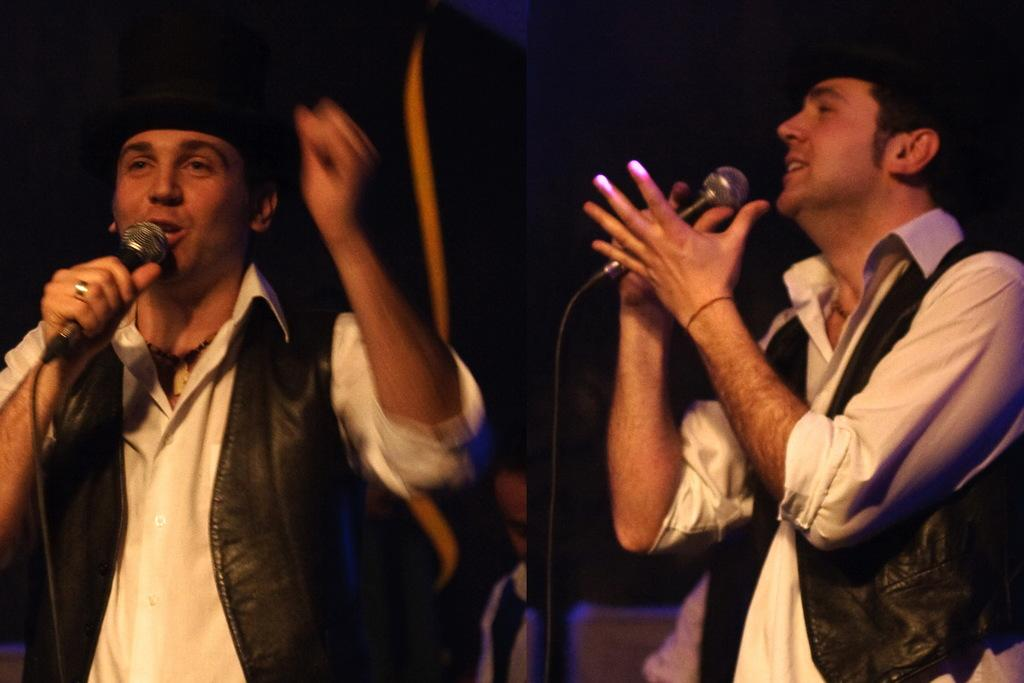What is happening in the image involving a group of people? There is a group of people in the image, and two persons are singing. How are the singers amplifying their voices in the image? The singers are using microphones in the image. What type of engine can be seen powering the hand in the image? There is no engine or hand present in the image; it features a group of people with two singers using microphones. 